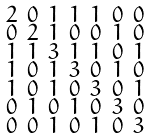<formula> <loc_0><loc_0><loc_500><loc_500>\begin{smallmatrix} 2 & 0 & 1 & 1 & 1 & 0 & 0 \\ 0 & 2 & 1 & 0 & 0 & 1 & 0 \\ 1 & 1 & 3 & 1 & 1 & 0 & 1 \\ 1 & 0 & 1 & 3 & 0 & 1 & 0 \\ 1 & 0 & 1 & 0 & 3 & 0 & 1 \\ 0 & 1 & 0 & 1 & 0 & 3 & 0 \\ 0 & 0 & 1 & 0 & 1 & 0 & 3 \end{smallmatrix}</formula> 